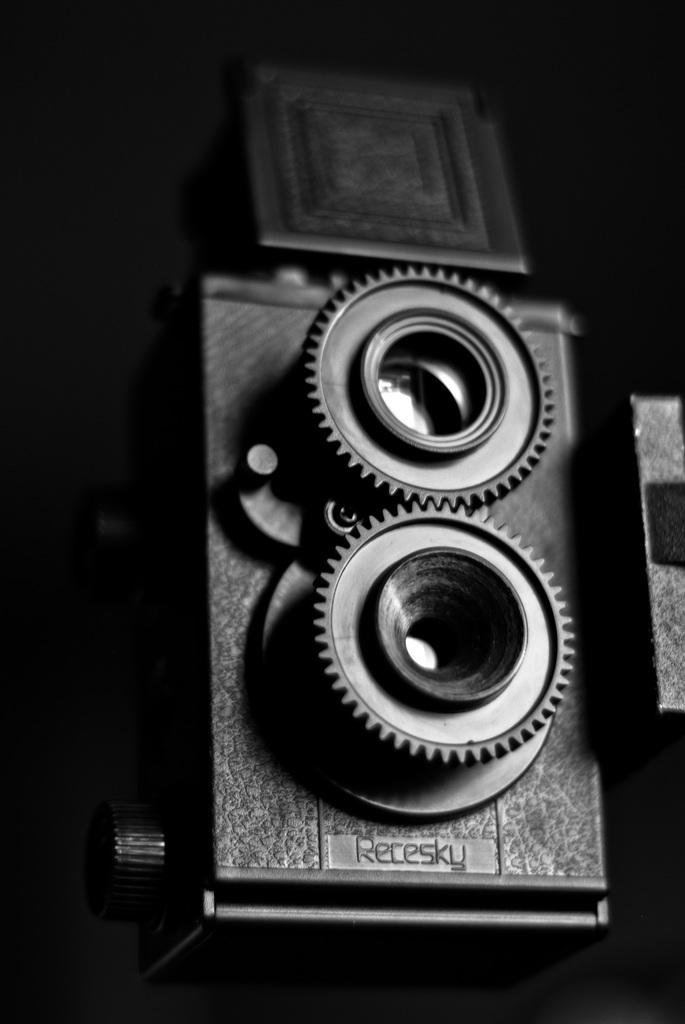What is the main object in the image? There is a camera in the image. What part of the camera is specifically mentioned in the facts? The camera has a camera lens. Where is the camera and lens located? The camera and lens are on a surface. How many tickets are being distributed by the camera in the image? There are no tickets mentioned or depicted in the image; it features a camera and lens on a surface. 